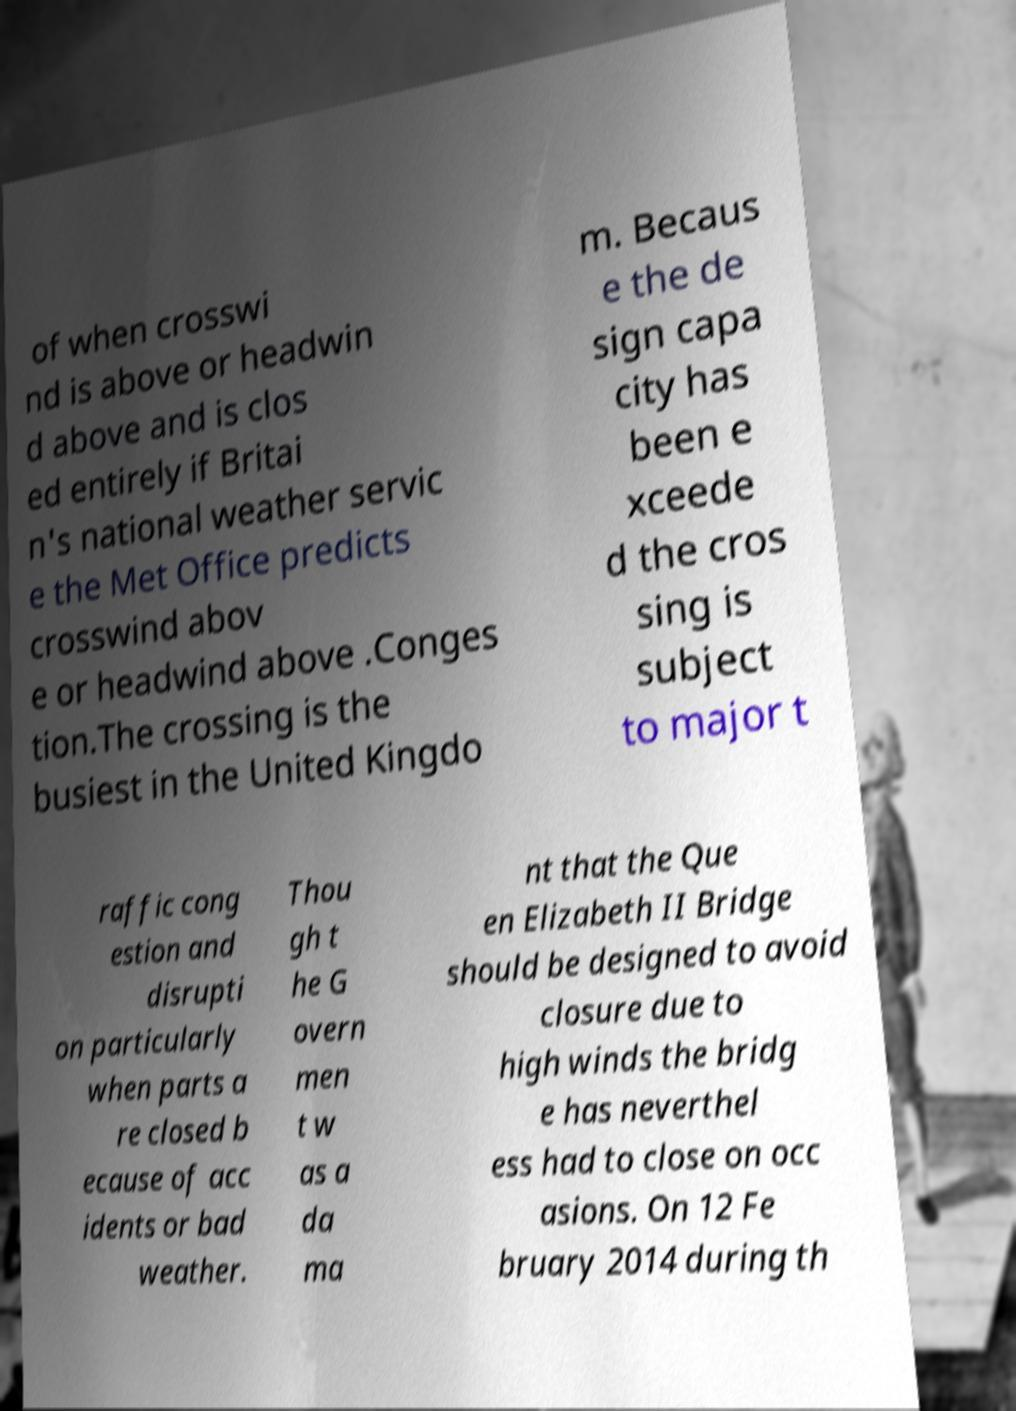Could you assist in decoding the text presented in this image and type it out clearly? of when crosswi nd is above or headwin d above and is clos ed entirely if Britai n's national weather servic e the Met Office predicts crosswind abov e or headwind above .Conges tion.The crossing is the busiest in the United Kingdo m. Becaus e the de sign capa city has been e xceede d the cros sing is subject to major t raffic cong estion and disrupti on particularly when parts a re closed b ecause of acc idents or bad weather. Thou gh t he G overn men t w as a da ma nt that the Que en Elizabeth II Bridge should be designed to avoid closure due to high winds the bridg e has neverthel ess had to close on occ asions. On 12 Fe bruary 2014 during th 